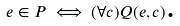<formula> <loc_0><loc_0><loc_500><loc_500>e \in P \iff ( \forall c ) Q ( e , c ) \text {.}</formula> 